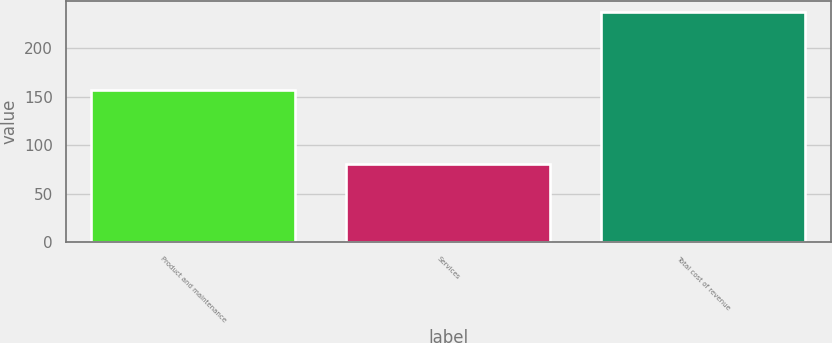<chart> <loc_0><loc_0><loc_500><loc_500><bar_chart><fcel>Product and maintenance<fcel>Services<fcel>Total cost of revenue<nl><fcel>156.7<fcel>80.7<fcel>237.4<nl></chart> 